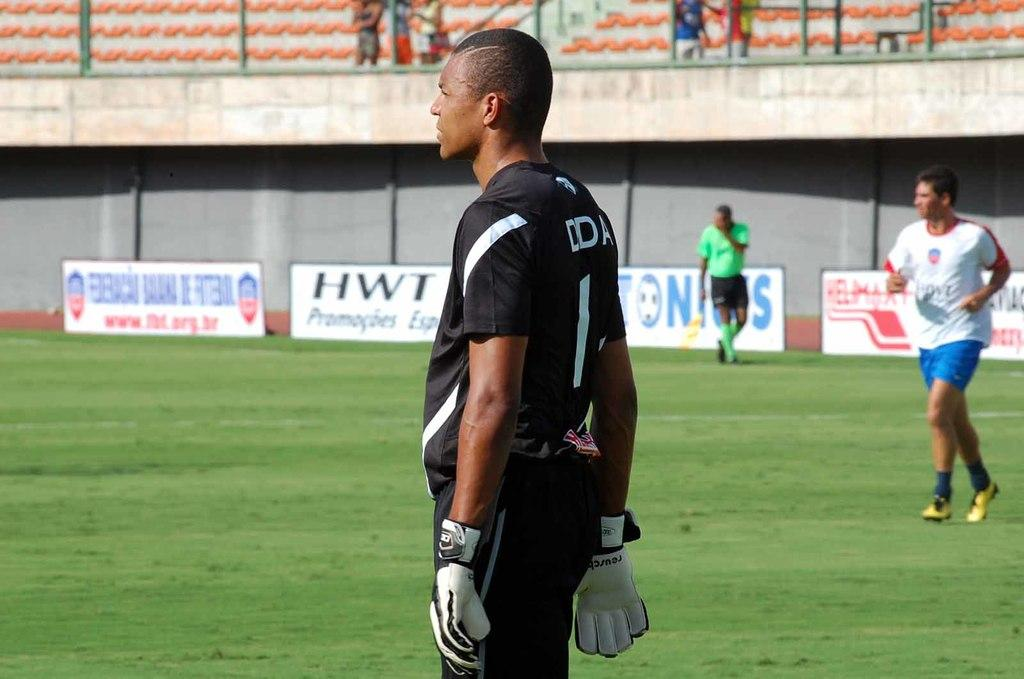What is the primary location of the people in the image? The people are standing on the ground in the image. Are there any other surfaces that people are standing on in the image? Yes, some people are standing on the floor in the image. What can be seen in the background of the image? There are walls and advertisement boards visible in the background of the image. What type of star can be seen on the receipt in the image? There is no receipt or star present in the image. 